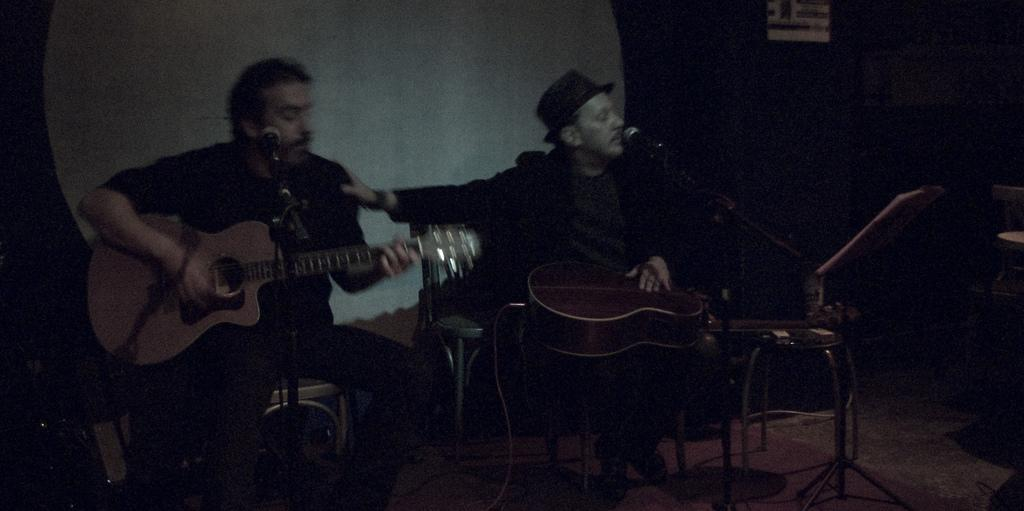How many people are in the image? There are two men in the image. What are the men doing in the image? The men are sitting in the image. What are the men holding in the image? The men are holding guitars in the image. What is in front of the men in the image? There are mice in front of the men in the image. What type of cheese is being offered to the men in the image? There is no cheese present in the image. How many apples are visible in the image? There are no apples visible in the image. 